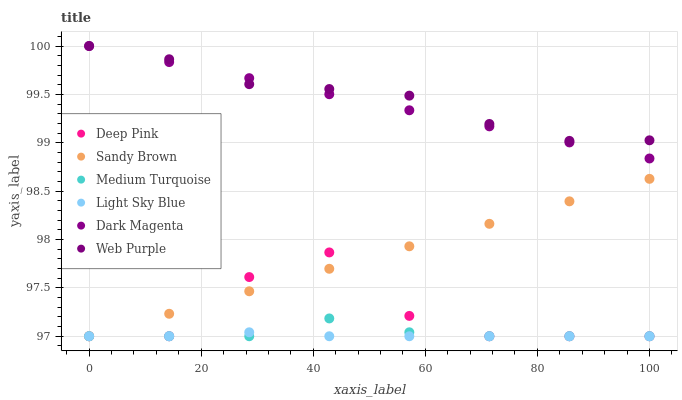Does Light Sky Blue have the minimum area under the curve?
Answer yes or no. Yes. Does Web Purple have the maximum area under the curve?
Answer yes or no. Yes. Does Dark Magenta have the minimum area under the curve?
Answer yes or no. No. Does Dark Magenta have the maximum area under the curve?
Answer yes or no. No. Is Dark Magenta the smoothest?
Answer yes or no. Yes. Is Deep Pink the roughest?
Answer yes or no. Yes. Is Web Purple the smoothest?
Answer yes or no. No. Is Web Purple the roughest?
Answer yes or no. No. Does Deep Pink have the lowest value?
Answer yes or no. Yes. Does Dark Magenta have the lowest value?
Answer yes or no. No. Does Web Purple have the highest value?
Answer yes or no. Yes. Does Light Sky Blue have the highest value?
Answer yes or no. No. Is Sandy Brown less than Dark Magenta?
Answer yes or no. Yes. Is Dark Magenta greater than Medium Turquoise?
Answer yes or no. Yes. Does Deep Pink intersect Sandy Brown?
Answer yes or no. Yes. Is Deep Pink less than Sandy Brown?
Answer yes or no. No. Is Deep Pink greater than Sandy Brown?
Answer yes or no. No. Does Sandy Brown intersect Dark Magenta?
Answer yes or no. No. 